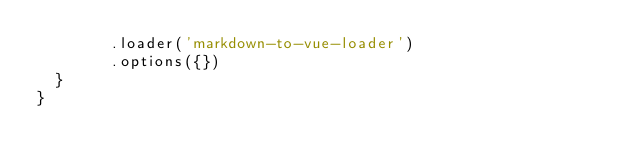Convert code to text. <code><loc_0><loc_0><loc_500><loc_500><_JavaScript_>        .loader('markdown-to-vue-loader')
        .options({})
  }
}
</code> 